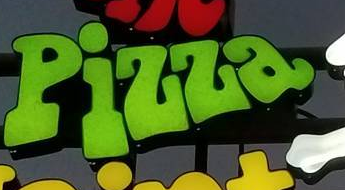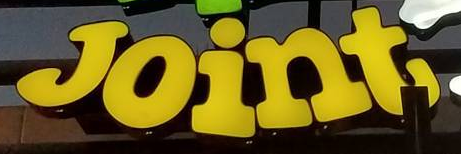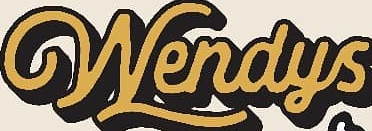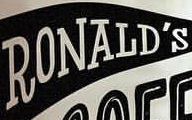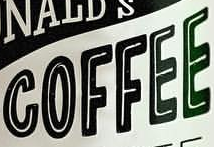Identify the words shown in these images in order, separated by a semicolon. Pizza; Joint; Wendys; RONALD'S; COFFEE 